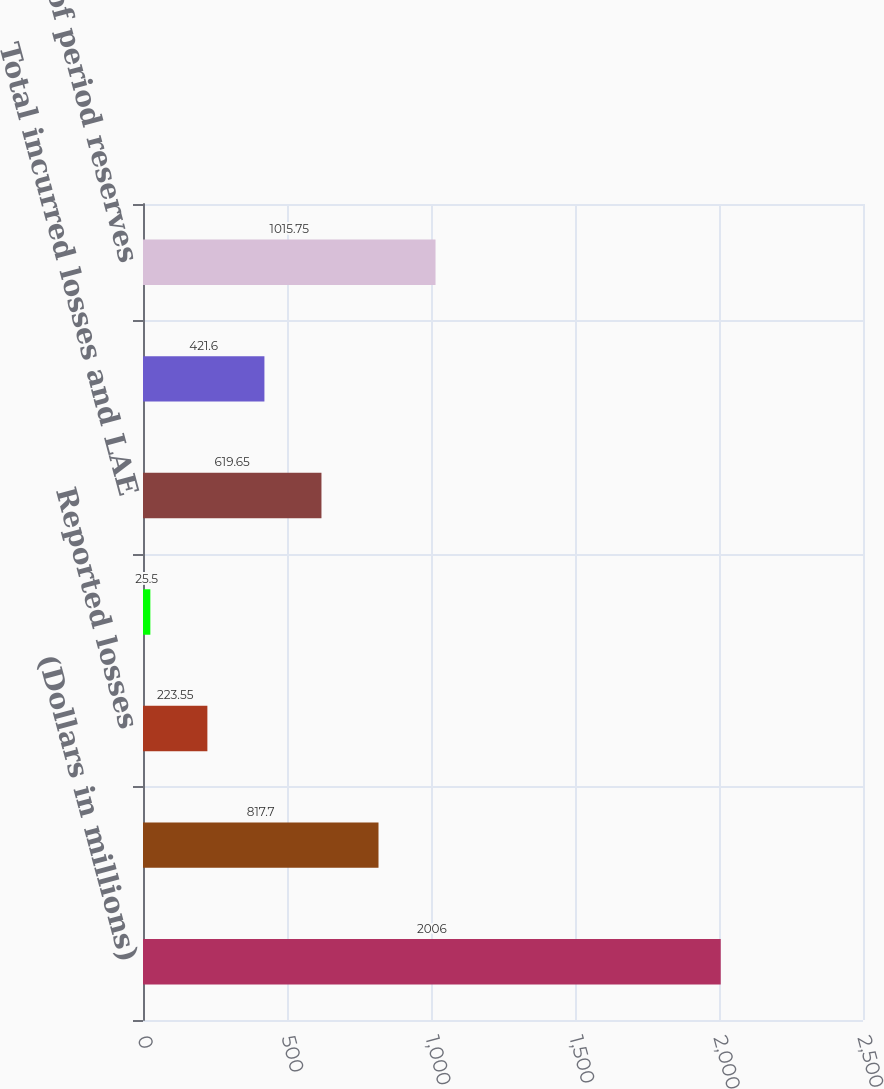<chart> <loc_0><loc_0><loc_500><loc_500><bar_chart><fcel>(Dollars in millions)<fcel>Beginning of period reserves<fcel>Reported losses<fcel>Change in IBNR<fcel>Total incurred losses and LAE<fcel>Paid losses<fcel>End of period reserves<nl><fcel>2006<fcel>817.7<fcel>223.55<fcel>25.5<fcel>619.65<fcel>421.6<fcel>1015.75<nl></chart> 